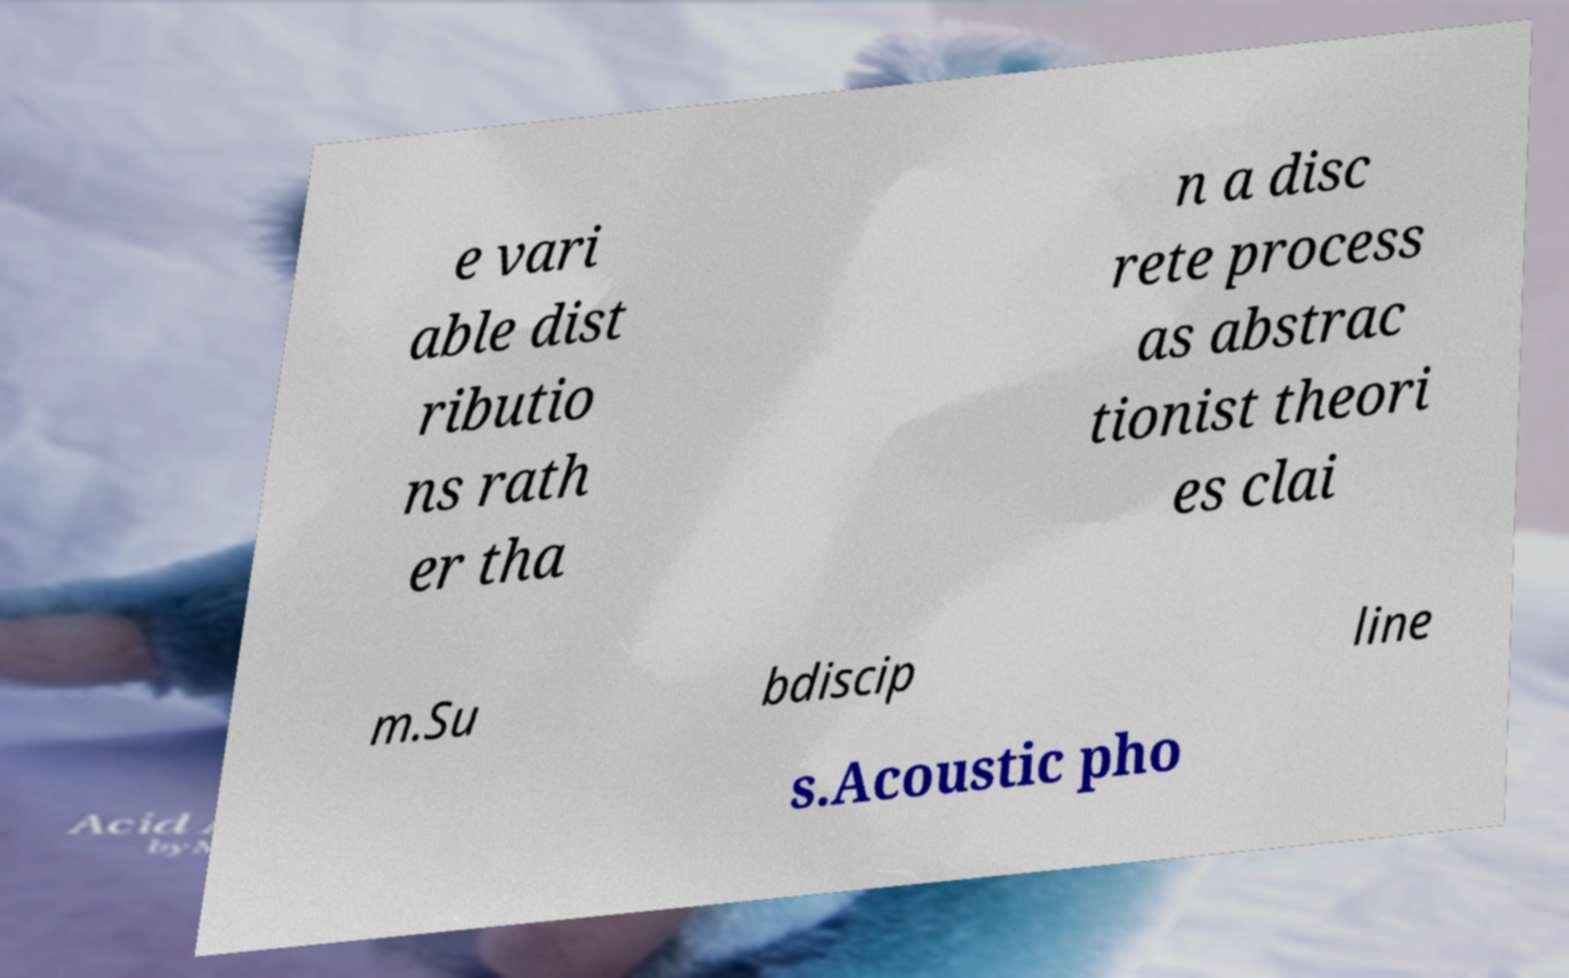Please identify and transcribe the text found in this image. e vari able dist ributio ns rath er tha n a disc rete process as abstrac tionist theori es clai m.Su bdiscip line s.Acoustic pho 